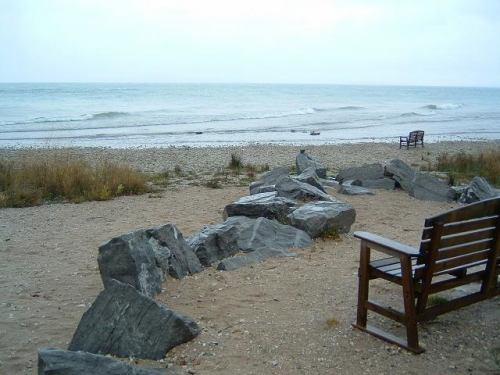What is the bench made of?
Keep it brief. Wood. Is this water safe for surfing?
Be succinct. Yes. What is the ground consisting of?
Write a very short answer. Rocks. Is the water choppy?
Short answer required. Yes. 